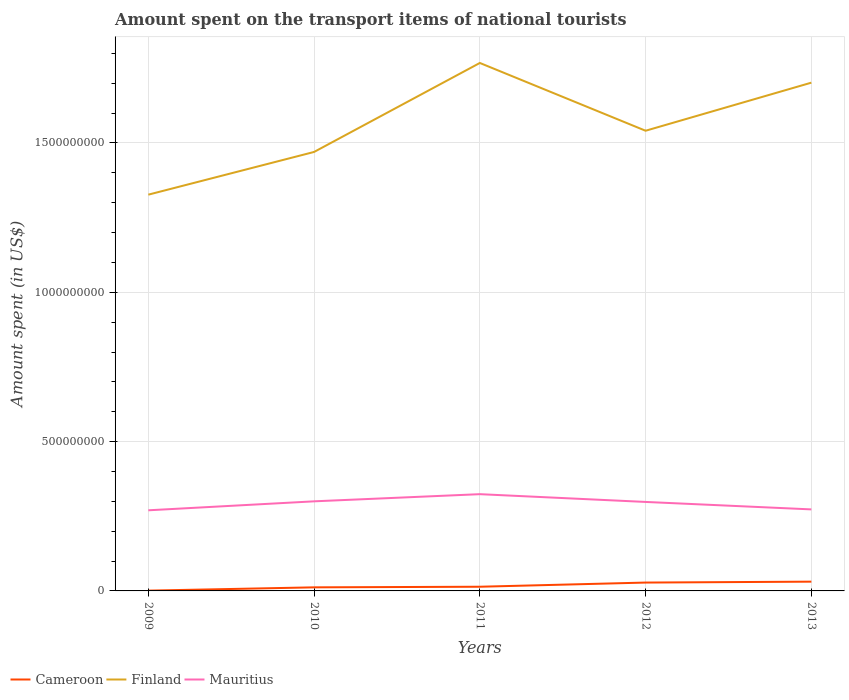Does the line corresponding to Mauritius intersect with the line corresponding to Cameroon?
Offer a very short reply. No. Across all years, what is the maximum amount spent on the transport items of national tourists in Cameroon?
Your answer should be very brief. 1.00e+06. What is the total amount spent on the transport items of national tourists in Finland in the graph?
Give a very brief answer. -7.10e+07. What is the difference between the highest and the second highest amount spent on the transport items of national tourists in Finland?
Provide a succinct answer. 4.41e+08. What is the difference between the highest and the lowest amount spent on the transport items of national tourists in Mauritius?
Offer a terse response. 3. Is the amount spent on the transport items of national tourists in Mauritius strictly greater than the amount spent on the transport items of national tourists in Cameroon over the years?
Offer a terse response. No. Are the values on the major ticks of Y-axis written in scientific E-notation?
Provide a short and direct response. No. Does the graph contain any zero values?
Ensure brevity in your answer.  No. Does the graph contain grids?
Offer a very short reply. Yes. Where does the legend appear in the graph?
Give a very brief answer. Bottom left. How are the legend labels stacked?
Provide a succinct answer. Horizontal. What is the title of the graph?
Your response must be concise. Amount spent on the transport items of national tourists. What is the label or title of the X-axis?
Give a very brief answer. Years. What is the label or title of the Y-axis?
Keep it short and to the point. Amount spent (in US$). What is the Amount spent (in US$) of Cameroon in 2009?
Your response must be concise. 1.00e+06. What is the Amount spent (in US$) in Finland in 2009?
Provide a short and direct response. 1.33e+09. What is the Amount spent (in US$) in Mauritius in 2009?
Offer a very short reply. 2.70e+08. What is the Amount spent (in US$) of Finland in 2010?
Ensure brevity in your answer.  1.47e+09. What is the Amount spent (in US$) of Mauritius in 2010?
Your response must be concise. 3.00e+08. What is the Amount spent (in US$) of Cameroon in 2011?
Ensure brevity in your answer.  1.40e+07. What is the Amount spent (in US$) in Finland in 2011?
Provide a succinct answer. 1.77e+09. What is the Amount spent (in US$) of Mauritius in 2011?
Your response must be concise. 3.24e+08. What is the Amount spent (in US$) in Cameroon in 2012?
Provide a succinct answer. 2.80e+07. What is the Amount spent (in US$) in Finland in 2012?
Make the answer very short. 1.54e+09. What is the Amount spent (in US$) of Mauritius in 2012?
Provide a short and direct response. 2.98e+08. What is the Amount spent (in US$) in Cameroon in 2013?
Offer a very short reply. 3.10e+07. What is the Amount spent (in US$) of Finland in 2013?
Your answer should be compact. 1.70e+09. What is the Amount spent (in US$) of Mauritius in 2013?
Provide a short and direct response. 2.73e+08. Across all years, what is the maximum Amount spent (in US$) of Cameroon?
Give a very brief answer. 3.10e+07. Across all years, what is the maximum Amount spent (in US$) in Finland?
Give a very brief answer. 1.77e+09. Across all years, what is the maximum Amount spent (in US$) in Mauritius?
Make the answer very short. 3.24e+08. Across all years, what is the minimum Amount spent (in US$) of Finland?
Offer a terse response. 1.33e+09. Across all years, what is the minimum Amount spent (in US$) in Mauritius?
Your answer should be very brief. 2.70e+08. What is the total Amount spent (in US$) of Cameroon in the graph?
Keep it short and to the point. 8.60e+07. What is the total Amount spent (in US$) in Finland in the graph?
Your answer should be compact. 7.81e+09. What is the total Amount spent (in US$) of Mauritius in the graph?
Make the answer very short. 1.46e+09. What is the difference between the Amount spent (in US$) in Cameroon in 2009 and that in 2010?
Provide a short and direct response. -1.10e+07. What is the difference between the Amount spent (in US$) in Finland in 2009 and that in 2010?
Your answer should be very brief. -1.43e+08. What is the difference between the Amount spent (in US$) of Mauritius in 2009 and that in 2010?
Make the answer very short. -3.00e+07. What is the difference between the Amount spent (in US$) of Cameroon in 2009 and that in 2011?
Make the answer very short. -1.30e+07. What is the difference between the Amount spent (in US$) of Finland in 2009 and that in 2011?
Give a very brief answer. -4.41e+08. What is the difference between the Amount spent (in US$) of Mauritius in 2009 and that in 2011?
Your answer should be very brief. -5.40e+07. What is the difference between the Amount spent (in US$) in Cameroon in 2009 and that in 2012?
Make the answer very short. -2.70e+07. What is the difference between the Amount spent (in US$) in Finland in 2009 and that in 2012?
Provide a short and direct response. -2.14e+08. What is the difference between the Amount spent (in US$) in Mauritius in 2009 and that in 2012?
Your answer should be compact. -2.80e+07. What is the difference between the Amount spent (in US$) of Cameroon in 2009 and that in 2013?
Provide a succinct answer. -3.00e+07. What is the difference between the Amount spent (in US$) in Finland in 2009 and that in 2013?
Offer a very short reply. -3.75e+08. What is the difference between the Amount spent (in US$) of Cameroon in 2010 and that in 2011?
Ensure brevity in your answer.  -2.00e+06. What is the difference between the Amount spent (in US$) in Finland in 2010 and that in 2011?
Your answer should be very brief. -2.98e+08. What is the difference between the Amount spent (in US$) in Mauritius in 2010 and that in 2011?
Your response must be concise. -2.40e+07. What is the difference between the Amount spent (in US$) of Cameroon in 2010 and that in 2012?
Your response must be concise. -1.60e+07. What is the difference between the Amount spent (in US$) in Finland in 2010 and that in 2012?
Your response must be concise. -7.10e+07. What is the difference between the Amount spent (in US$) of Mauritius in 2010 and that in 2012?
Offer a very short reply. 2.00e+06. What is the difference between the Amount spent (in US$) of Cameroon in 2010 and that in 2013?
Keep it short and to the point. -1.90e+07. What is the difference between the Amount spent (in US$) in Finland in 2010 and that in 2013?
Offer a very short reply. -2.32e+08. What is the difference between the Amount spent (in US$) of Mauritius in 2010 and that in 2013?
Keep it short and to the point. 2.70e+07. What is the difference between the Amount spent (in US$) in Cameroon in 2011 and that in 2012?
Provide a succinct answer. -1.40e+07. What is the difference between the Amount spent (in US$) of Finland in 2011 and that in 2012?
Give a very brief answer. 2.27e+08. What is the difference between the Amount spent (in US$) of Mauritius in 2011 and that in 2012?
Make the answer very short. 2.60e+07. What is the difference between the Amount spent (in US$) in Cameroon in 2011 and that in 2013?
Your answer should be compact. -1.70e+07. What is the difference between the Amount spent (in US$) of Finland in 2011 and that in 2013?
Give a very brief answer. 6.60e+07. What is the difference between the Amount spent (in US$) of Mauritius in 2011 and that in 2013?
Give a very brief answer. 5.10e+07. What is the difference between the Amount spent (in US$) in Cameroon in 2012 and that in 2013?
Provide a short and direct response. -3.00e+06. What is the difference between the Amount spent (in US$) in Finland in 2012 and that in 2013?
Your answer should be very brief. -1.61e+08. What is the difference between the Amount spent (in US$) in Mauritius in 2012 and that in 2013?
Make the answer very short. 2.50e+07. What is the difference between the Amount spent (in US$) of Cameroon in 2009 and the Amount spent (in US$) of Finland in 2010?
Make the answer very short. -1.47e+09. What is the difference between the Amount spent (in US$) in Cameroon in 2009 and the Amount spent (in US$) in Mauritius in 2010?
Your response must be concise. -2.99e+08. What is the difference between the Amount spent (in US$) in Finland in 2009 and the Amount spent (in US$) in Mauritius in 2010?
Give a very brief answer. 1.03e+09. What is the difference between the Amount spent (in US$) in Cameroon in 2009 and the Amount spent (in US$) in Finland in 2011?
Offer a terse response. -1.77e+09. What is the difference between the Amount spent (in US$) of Cameroon in 2009 and the Amount spent (in US$) of Mauritius in 2011?
Keep it short and to the point. -3.23e+08. What is the difference between the Amount spent (in US$) in Finland in 2009 and the Amount spent (in US$) in Mauritius in 2011?
Provide a short and direct response. 1.00e+09. What is the difference between the Amount spent (in US$) of Cameroon in 2009 and the Amount spent (in US$) of Finland in 2012?
Provide a short and direct response. -1.54e+09. What is the difference between the Amount spent (in US$) of Cameroon in 2009 and the Amount spent (in US$) of Mauritius in 2012?
Your answer should be compact. -2.97e+08. What is the difference between the Amount spent (in US$) of Finland in 2009 and the Amount spent (in US$) of Mauritius in 2012?
Your answer should be compact. 1.03e+09. What is the difference between the Amount spent (in US$) in Cameroon in 2009 and the Amount spent (in US$) in Finland in 2013?
Offer a very short reply. -1.70e+09. What is the difference between the Amount spent (in US$) in Cameroon in 2009 and the Amount spent (in US$) in Mauritius in 2013?
Ensure brevity in your answer.  -2.72e+08. What is the difference between the Amount spent (in US$) in Finland in 2009 and the Amount spent (in US$) in Mauritius in 2013?
Keep it short and to the point. 1.05e+09. What is the difference between the Amount spent (in US$) of Cameroon in 2010 and the Amount spent (in US$) of Finland in 2011?
Offer a terse response. -1.76e+09. What is the difference between the Amount spent (in US$) of Cameroon in 2010 and the Amount spent (in US$) of Mauritius in 2011?
Give a very brief answer. -3.12e+08. What is the difference between the Amount spent (in US$) of Finland in 2010 and the Amount spent (in US$) of Mauritius in 2011?
Keep it short and to the point. 1.15e+09. What is the difference between the Amount spent (in US$) of Cameroon in 2010 and the Amount spent (in US$) of Finland in 2012?
Provide a succinct answer. -1.53e+09. What is the difference between the Amount spent (in US$) in Cameroon in 2010 and the Amount spent (in US$) in Mauritius in 2012?
Your answer should be very brief. -2.86e+08. What is the difference between the Amount spent (in US$) in Finland in 2010 and the Amount spent (in US$) in Mauritius in 2012?
Give a very brief answer. 1.17e+09. What is the difference between the Amount spent (in US$) in Cameroon in 2010 and the Amount spent (in US$) in Finland in 2013?
Keep it short and to the point. -1.69e+09. What is the difference between the Amount spent (in US$) of Cameroon in 2010 and the Amount spent (in US$) of Mauritius in 2013?
Keep it short and to the point. -2.61e+08. What is the difference between the Amount spent (in US$) of Finland in 2010 and the Amount spent (in US$) of Mauritius in 2013?
Give a very brief answer. 1.20e+09. What is the difference between the Amount spent (in US$) in Cameroon in 2011 and the Amount spent (in US$) in Finland in 2012?
Your answer should be compact. -1.53e+09. What is the difference between the Amount spent (in US$) in Cameroon in 2011 and the Amount spent (in US$) in Mauritius in 2012?
Your answer should be very brief. -2.84e+08. What is the difference between the Amount spent (in US$) of Finland in 2011 and the Amount spent (in US$) of Mauritius in 2012?
Ensure brevity in your answer.  1.47e+09. What is the difference between the Amount spent (in US$) of Cameroon in 2011 and the Amount spent (in US$) of Finland in 2013?
Offer a terse response. -1.69e+09. What is the difference between the Amount spent (in US$) of Cameroon in 2011 and the Amount spent (in US$) of Mauritius in 2013?
Ensure brevity in your answer.  -2.59e+08. What is the difference between the Amount spent (in US$) in Finland in 2011 and the Amount spent (in US$) in Mauritius in 2013?
Keep it short and to the point. 1.50e+09. What is the difference between the Amount spent (in US$) in Cameroon in 2012 and the Amount spent (in US$) in Finland in 2013?
Give a very brief answer. -1.67e+09. What is the difference between the Amount spent (in US$) in Cameroon in 2012 and the Amount spent (in US$) in Mauritius in 2013?
Give a very brief answer. -2.45e+08. What is the difference between the Amount spent (in US$) of Finland in 2012 and the Amount spent (in US$) of Mauritius in 2013?
Give a very brief answer. 1.27e+09. What is the average Amount spent (in US$) of Cameroon per year?
Your answer should be compact. 1.72e+07. What is the average Amount spent (in US$) of Finland per year?
Your answer should be compact. 1.56e+09. What is the average Amount spent (in US$) in Mauritius per year?
Keep it short and to the point. 2.93e+08. In the year 2009, what is the difference between the Amount spent (in US$) of Cameroon and Amount spent (in US$) of Finland?
Your answer should be very brief. -1.33e+09. In the year 2009, what is the difference between the Amount spent (in US$) of Cameroon and Amount spent (in US$) of Mauritius?
Your response must be concise. -2.69e+08. In the year 2009, what is the difference between the Amount spent (in US$) in Finland and Amount spent (in US$) in Mauritius?
Ensure brevity in your answer.  1.06e+09. In the year 2010, what is the difference between the Amount spent (in US$) of Cameroon and Amount spent (in US$) of Finland?
Give a very brief answer. -1.46e+09. In the year 2010, what is the difference between the Amount spent (in US$) in Cameroon and Amount spent (in US$) in Mauritius?
Offer a terse response. -2.88e+08. In the year 2010, what is the difference between the Amount spent (in US$) of Finland and Amount spent (in US$) of Mauritius?
Offer a terse response. 1.17e+09. In the year 2011, what is the difference between the Amount spent (in US$) of Cameroon and Amount spent (in US$) of Finland?
Make the answer very short. -1.75e+09. In the year 2011, what is the difference between the Amount spent (in US$) of Cameroon and Amount spent (in US$) of Mauritius?
Keep it short and to the point. -3.10e+08. In the year 2011, what is the difference between the Amount spent (in US$) of Finland and Amount spent (in US$) of Mauritius?
Your answer should be very brief. 1.44e+09. In the year 2012, what is the difference between the Amount spent (in US$) of Cameroon and Amount spent (in US$) of Finland?
Provide a succinct answer. -1.51e+09. In the year 2012, what is the difference between the Amount spent (in US$) of Cameroon and Amount spent (in US$) of Mauritius?
Make the answer very short. -2.70e+08. In the year 2012, what is the difference between the Amount spent (in US$) in Finland and Amount spent (in US$) in Mauritius?
Offer a very short reply. 1.24e+09. In the year 2013, what is the difference between the Amount spent (in US$) in Cameroon and Amount spent (in US$) in Finland?
Offer a very short reply. -1.67e+09. In the year 2013, what is the difference between the Amount spent (in US$) of Cameroon and Amount spent (in US$) of Mauritius?
Keep it short and to the point. -2.42e+08. In the year 2013, what is the difference between the Amount spent (in US$) in Finland and Amount spent (in US$) in Mauritius?
Your answer should be very brief. 1.43e+09. What is the ratio of the Amount spent (in US$) of Cameroon in 2009 to that in 2010?
Offer a very short reply. 0.08. What is the ratio of the Amount spent (in US$) of Finland in 2009 to that in 2010?
Your answer should be very brief. 0.9. What is the ratio of the Amount spent (in US$) in Mauritius in 2009 to that in 2010?
Make the answer very short. 0.9. What is the ratio of the Amount spent (in US$) of Cameroon in 2009 to that in 2011?
Keep it short and to the point. 0.07. What is the ratio of the Amount spent (in US$) of Finland in 2009 to that in 2011?
Make the answer very short. 0.75. What is the ratio of the Amount spent (in US$) in Mauritius in 2009 to that in 2011?
Your answer should be compact. 0.83. What is the ratio of the Amount spent (in US$) in Cameroon in 2009 to that in 2012?
Give a very brief answer. 0.04. What is the ratio of the Amount spent (in US$) of Finland in 2009 to that in 2012?
Provide a short and direct response. 0.86. What is the ratio of the Amount spent (in US$) in Mauritius in 2009 to that in 2012?
Offer a very short reply. 0.91. What is the ratio of the Amount spent (in US$) in Cameroon in 2009 to that in 2013?
Give a very brief answer. 0.03. What is the ratio of the Amount spent (in US$) in Finland in 2009 to that in 2013?
Ensure brevity in your answer.  0.78. What is the ratio of the Amount spent (in US$) in Mauritius in 2009 to that in 2013?
Ensure brevity in your answer.  0.99. What is the ratio of the Amount spent (in US$) of Cameroon in 2010 to that in 2011?
Offer a very short reply. 0.86. What is the ratio of the Amount spent (in US$) of Finland in 2010 to that in 2011?
Provide a succinct answer. 0.83. What is the ratio of the Amount spent (in US$) in Mauritius in 2010 to that in 2011?
Your response must be concise. 0.93. What is the ratio of the Amount spent (in US$) of Cameroon in 2010 to that in 2012?
Provide a succinct answer. 0.43. What is the ratio of the Amount spent (in US$) of Finland in 2010 to that in 2012?
Provide a short and direct response. 0.95. What is the ratio of the Amount spent (in US$) of Mauritius in 2010 to that in 2012?
Keep it short and to the point. 1.01. What is the ratio of the Amount spent (in US$) of Cameroon in 2010 to that in 2013?
Offer a very short reply. 0.39. What is the ratio of the Amount spent (in US$) in Finland in 2010 to that in 2013?
Offer a terse response. 0.86. What is the ratio of the Amount spent (in US$) in Mauritius in 2010 to that in 2013?
Keep it short and to the point. 1.1. What is the ratio of the Amount spent (in US$) of Cameroon in 2011 to that in 2012?
Offer a terse response. 0.5. What is the ratio of the Amount spent (in US$) in Finland in 2011 to that in 2012?
Ensure brevity in your answer.  1.15. What is the ratio of the Amount spent (in US$) in Mauritius in 2011 to that in 2012?
Make the answer very short. 1.09. What is the ratio of the Amount spent (in US$) of Cameroon in 2011 to that in 2013?
Give a very brief answer. 0.45. What is the ratio of the Amount spent (in US$) of Finland in 2011 to that in 2013?
Offer a terse response. 1.04. What is the ratio of the Amount spent (in US$) of Mauritius in 2011 to that in 2013?
Your answer should be very brief. 1.19. What is the ratio of the Amount spent (in US$) in Cameroon in 2012 to that in 2013?
Ensure brevity in your answer.  0.9. What is the ratio of the Amount spent (in US$) of Finland in 2012 to that in 2013?
Provide a short and direct response. 0.91. What is the ratio of the Amount spent (in US$) of Mauritius in 2012 to that in 2013?
Your answer should be very brief. 1.09. What is the difference between the highest and the second highest Amount spent (in US$) in Cameroon?
Offer a terse response. 3.00e+06. What is the difference between the highest and the second highest Amount spent (in US$) in Finland?
Your answer should be very brief. 6.60e+07. What is the difference between the highest and the second highest Amount spent (in US$) in Mauritius?
Your response must be concise. 2.40e+07. What is the difference between the highest and the lowest Amount spent (in US$) in Cameroon?
Offer a very short reply. 3.00e+07. What is the difference between the highest and the lowest Amount spent (in US$) in Finland?
Give a very brief answer. 4.41e+08. What is the difference between the highest and the lowest Amount spent (in US$) of Mauritius?
Provide a succinct answer. 5.40e+07. 